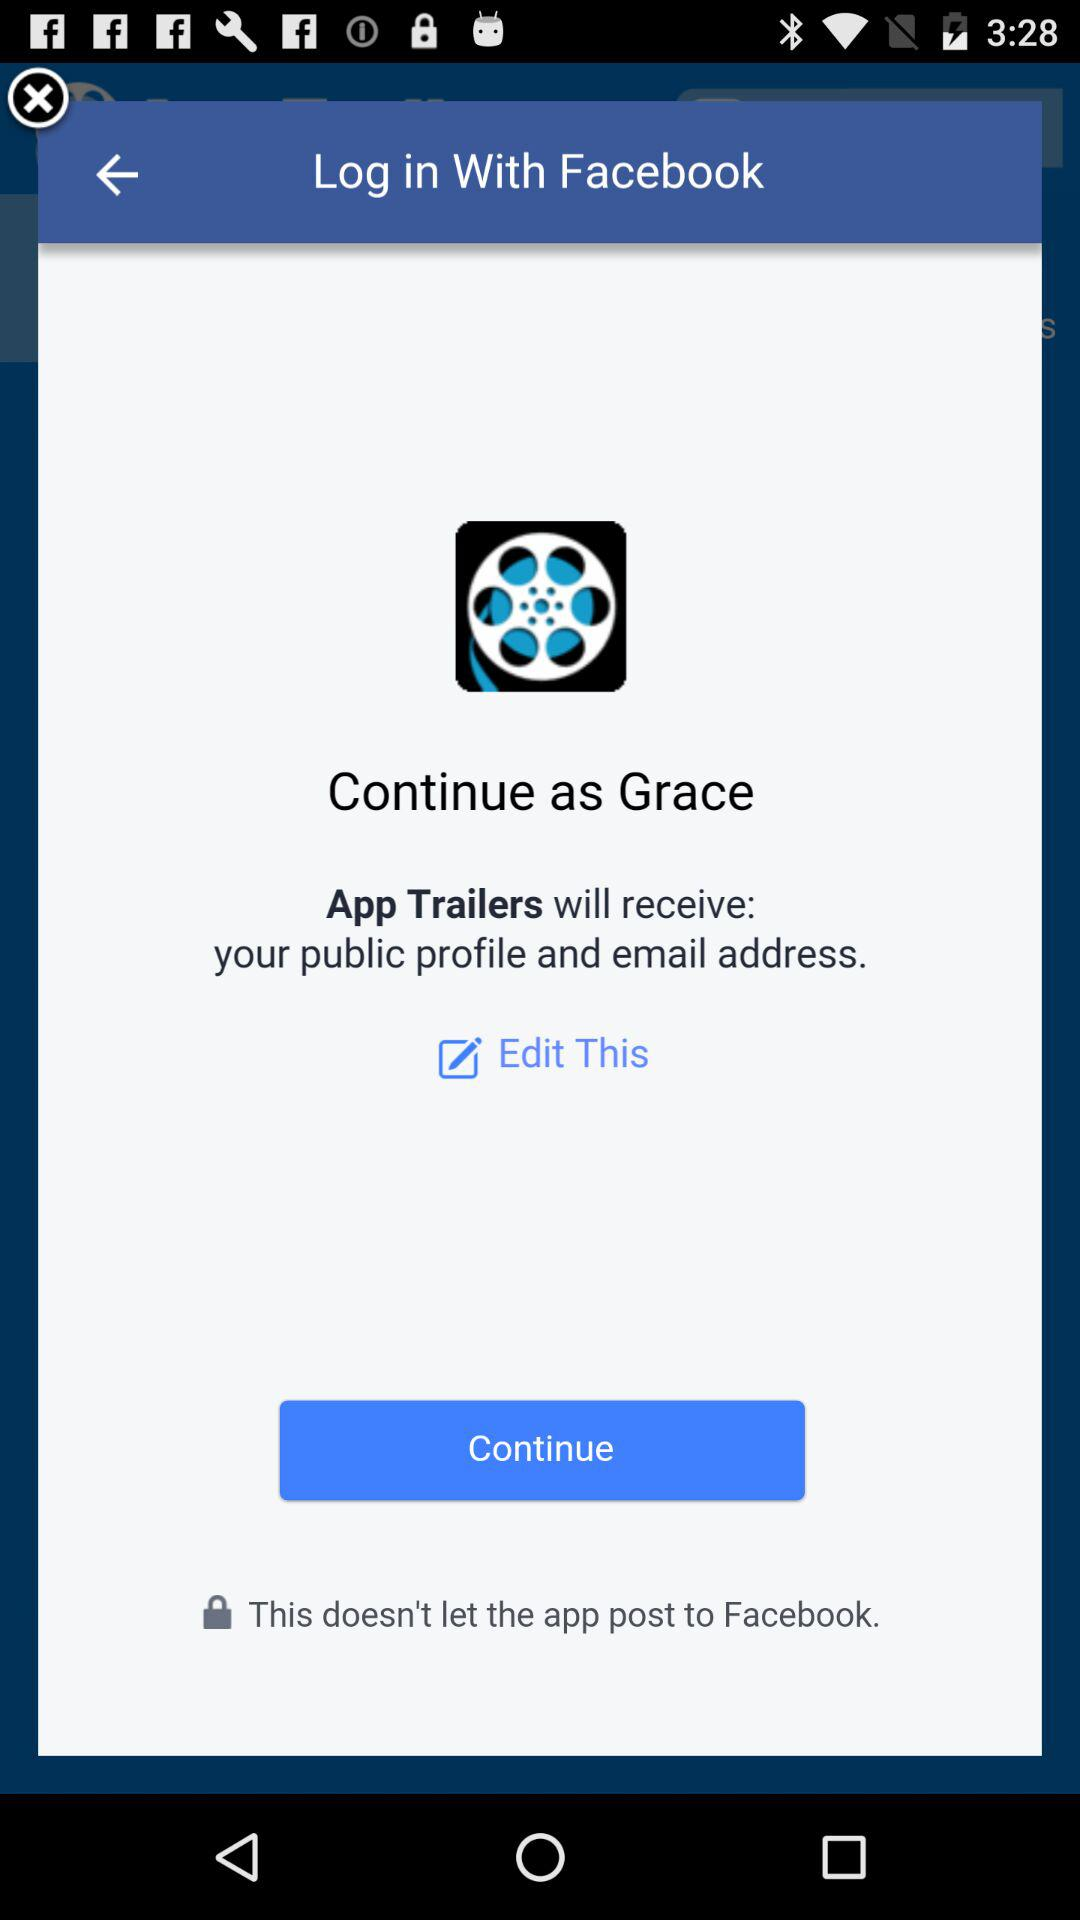What is the name of the user? The name of the user is Grace. 